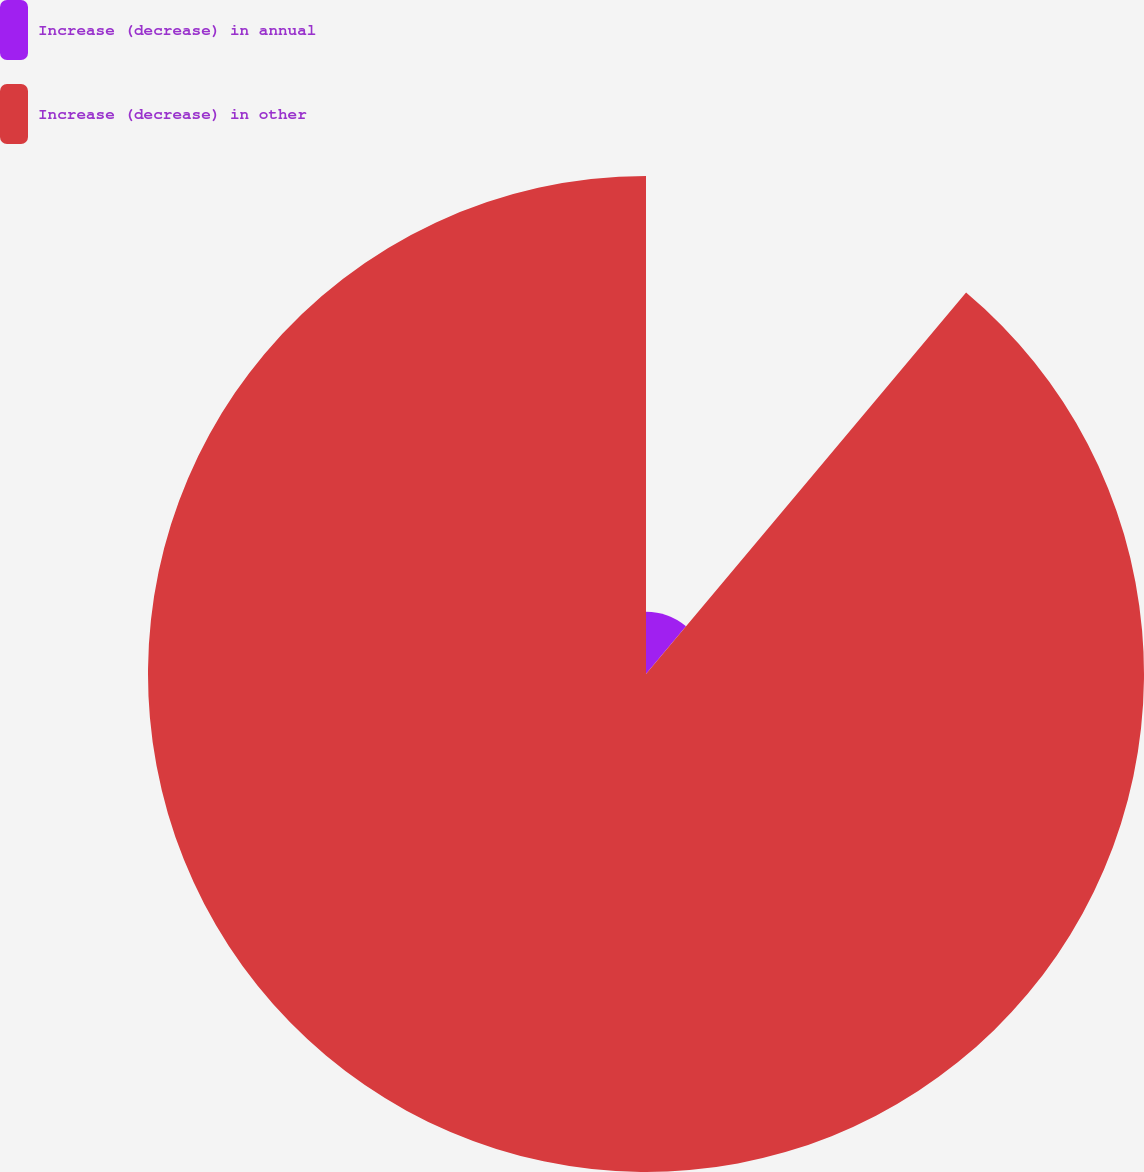Convert chart. <chart><loc_0><loc_0><loc_500><loc_500><pie_chart><fcel>Increase (decrease) in annual<fcel>Increase (decrease) in other<nl><fcel>11.11%<fcel>88.89%<nl></chart> 